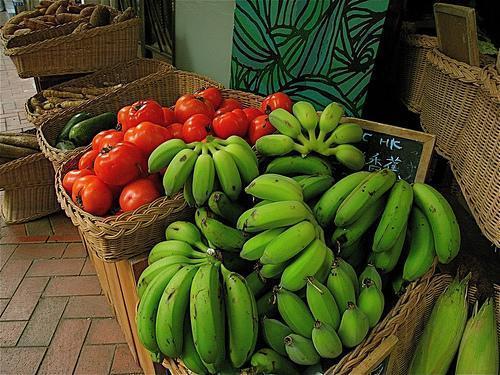How many people have gray hair?
Give a very brief answer. 0. 